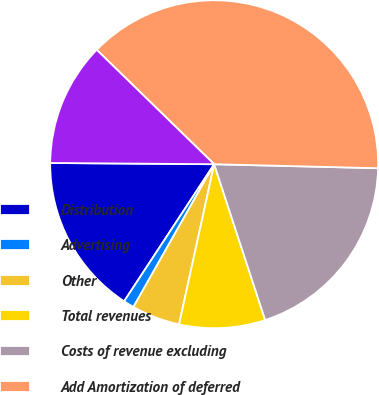Convert chart to OTSL. <chart><loc_0><loc_0><loc_500><loc_500><pie_chart><fcel>Distribution<fcel>Advertising<fcel>Other<fcel>Total revenues<fcel>Costs of revenue excluding<fcel>Add Amortization of deferred<fcel>Adjusted OIBDA<nl><fcel>15.87%<fcel>1.06%<fcel>4.76%<fcel>8.47%<fcel>19.58%<fcel>38.1%<fcel>12.17%<nl></chart> 